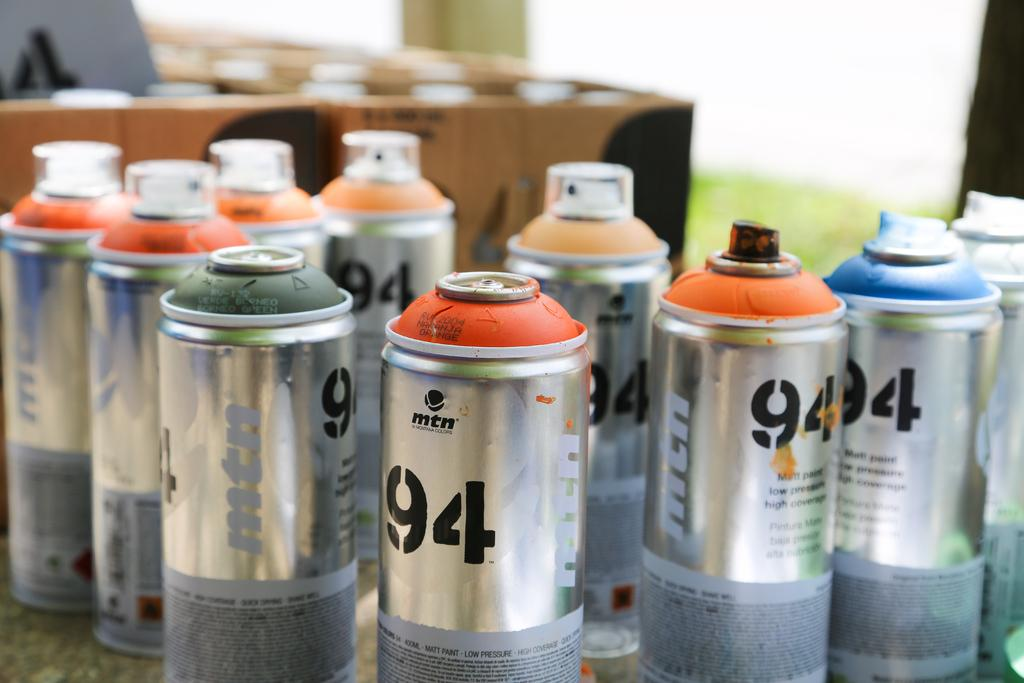Provide a one-sentence caption for the provided image. Bunch of spray cans that have the number 94 on it. 